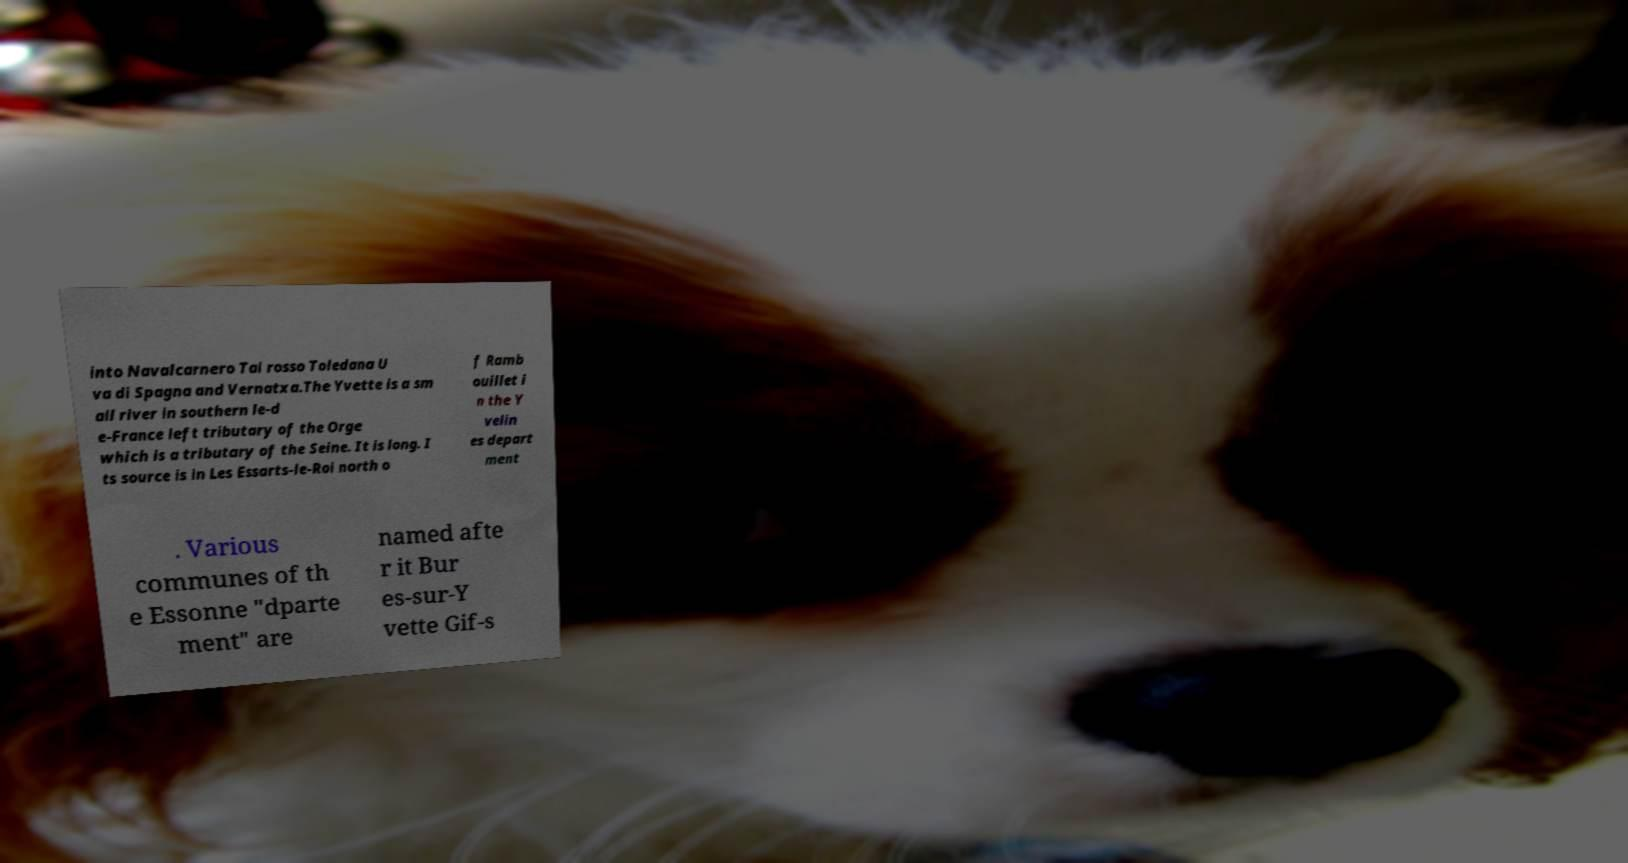Please read and relay the text visible in this image. What does it say? into Navalcarnero Tai rosso Toledana U va di Spagna and Vernatxa.The Yvette is a sm all river in southern le-d e-France left tributary of the Orge which is a tributary of the Seine. It is long. I ts source is in Les Essarts-le-Roi north o f Ramb ouillet i n the Y velin es depart ment . Various communes of th e Essonne "dparte ment" are named afte r it Bur es-sur-Y vette Gif-s 